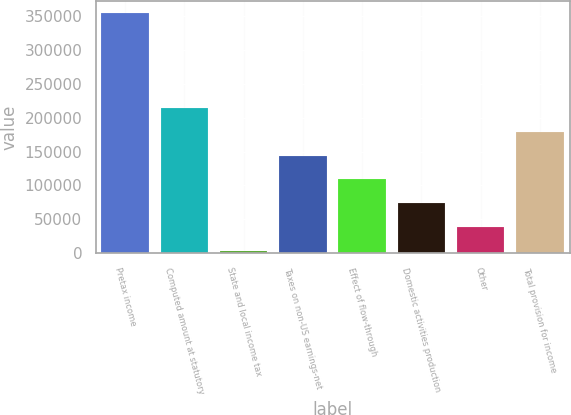Convert chart. <chart><loc_0><loc_0><loc_500><loc_500><bar_chart><fcel>Pretax income<fcel>Computed amount at statutory<fcel>State and local income tax<fcel>Taxes on non-US earnings-net<fcel>Effect of flow-through<fcel>Domestic activities production<fcel>Other<fcel>Total provision for income<nl><fcel>353129<fcel>213630<fcel>4382<fcel>143881<fcel>109006<fcel>74131.4<fcel>39256.7<fcel>178756<nl></chart> 